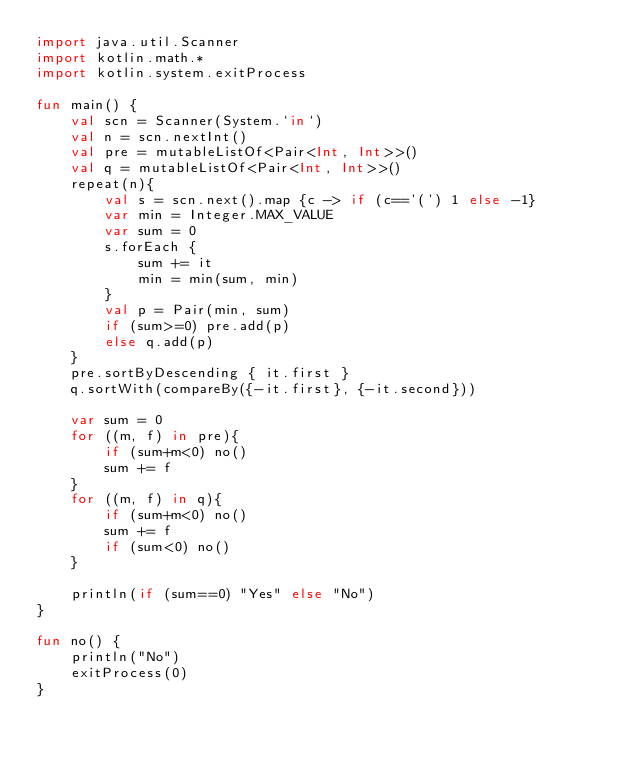<code> <loc_0><loc_0><loc_500><loc_500><_Kotlin_>import java.util.Scanner
import kotlin.math.*
import kotlin.system.exitProcess

fun main() {
    val scn = Scanner(System.`in`)
    val n = scn.nextInt()
    val pre = mutableListOf<Pair<Int, Int>>()
    val q = mutableListOf<Pair<Int, Int>>()
    repeat(n){
        val s = scn.next().map {c -> if (c=='(') 1 else -1}
        var min = Integer.MAX_VALUE
        var sum = 0
        s.forEach {
            sum += it
            min = min(sum, min)
        }
        val p = Pair(min, sum)
        if (sum>=0) pre.add(p)
        else q.add(p)
    }
    pre.sortByDescending { it.first }
    q.sortWith(compareBy({-it.first}, {-it.second}))
    
    var sum = 0
    for ((m, f) in pre){
        if (sum+m<0) no()
        sum += f
    }
    for ((m, f) in q){
        if (sum+m<0) no()
        sum += f
        if (sum<0) no()
    }
    
    println(if (sum==0) "Yes" else "No")
}

fun no() {
    println("No")
    exitProcess(0)
}</code> 